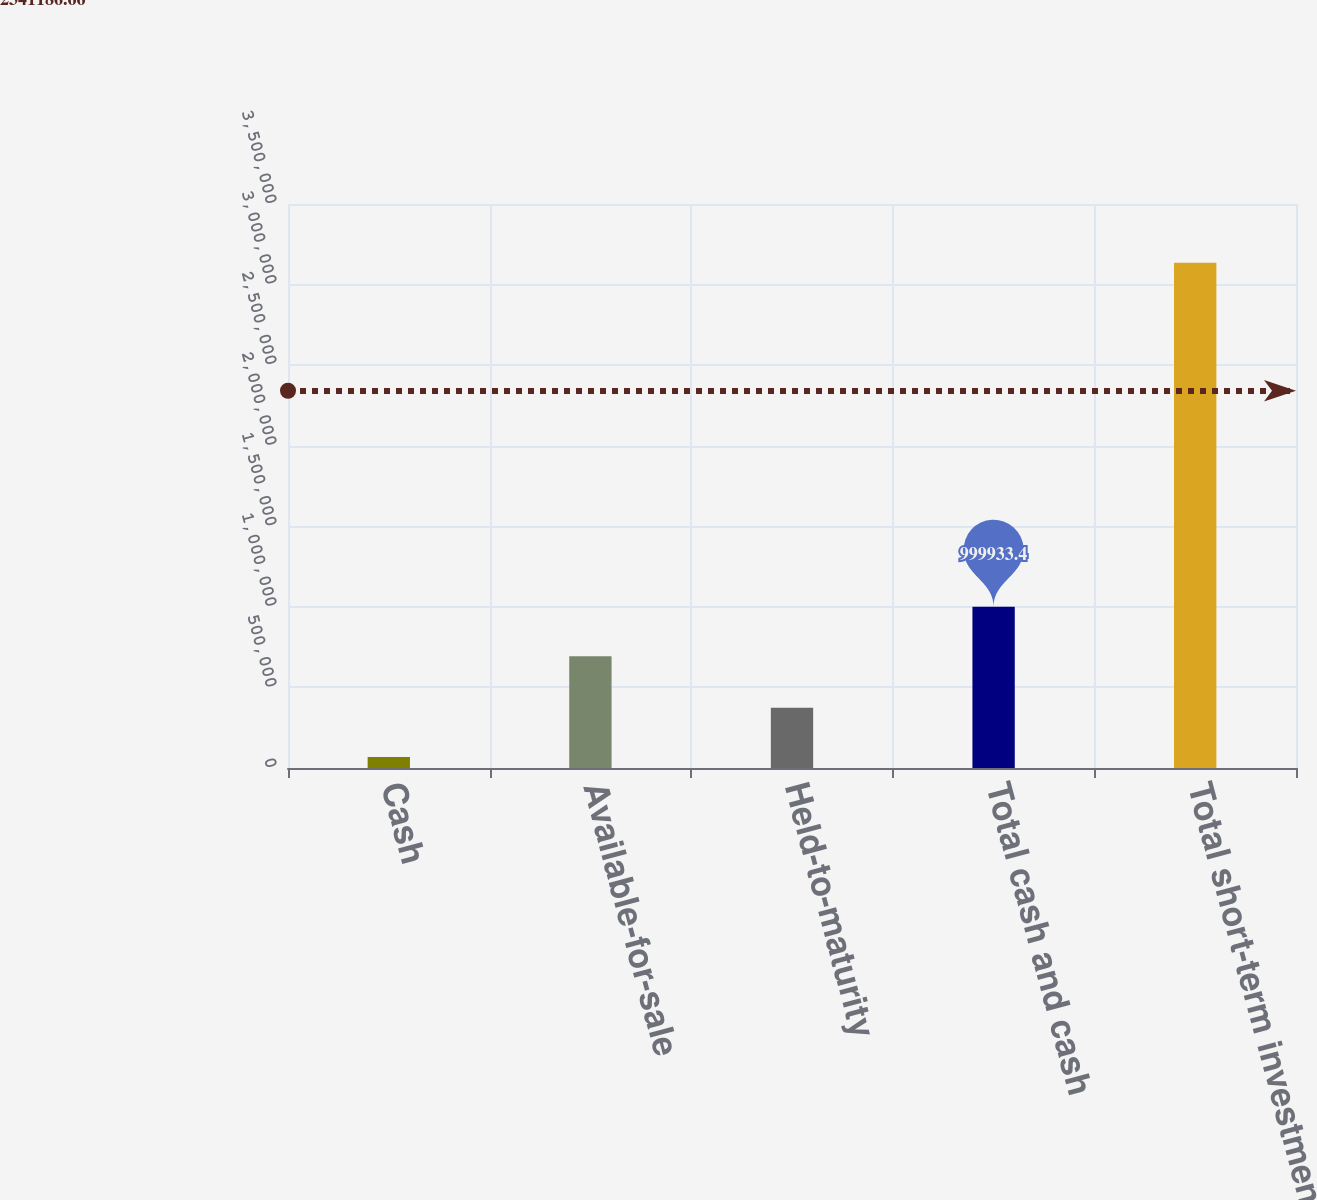Convert chart. <chart><loc_0><loc_0><loc_500><loc_500><bar_chart><fcel>Cash<fcel>Available-for-sale<fcel>Held-to-maturity<fcel>Total cash and cash<fcel>Total short-term investments<nl><fcel>67877<fcel>693255<fcel>374555<fcel>999933<fcel>3.13466e+06<nl></chart> 